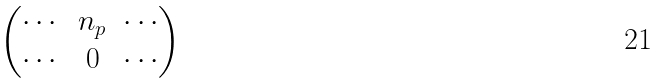<formula> <loc_0><loc_0><loc_500><loc_500>\begin{pmatrix} \cdots & n _ { p } & \cdots \\ \cdots & 0 & \cdots \\ \end{pmatrix}</formula> 